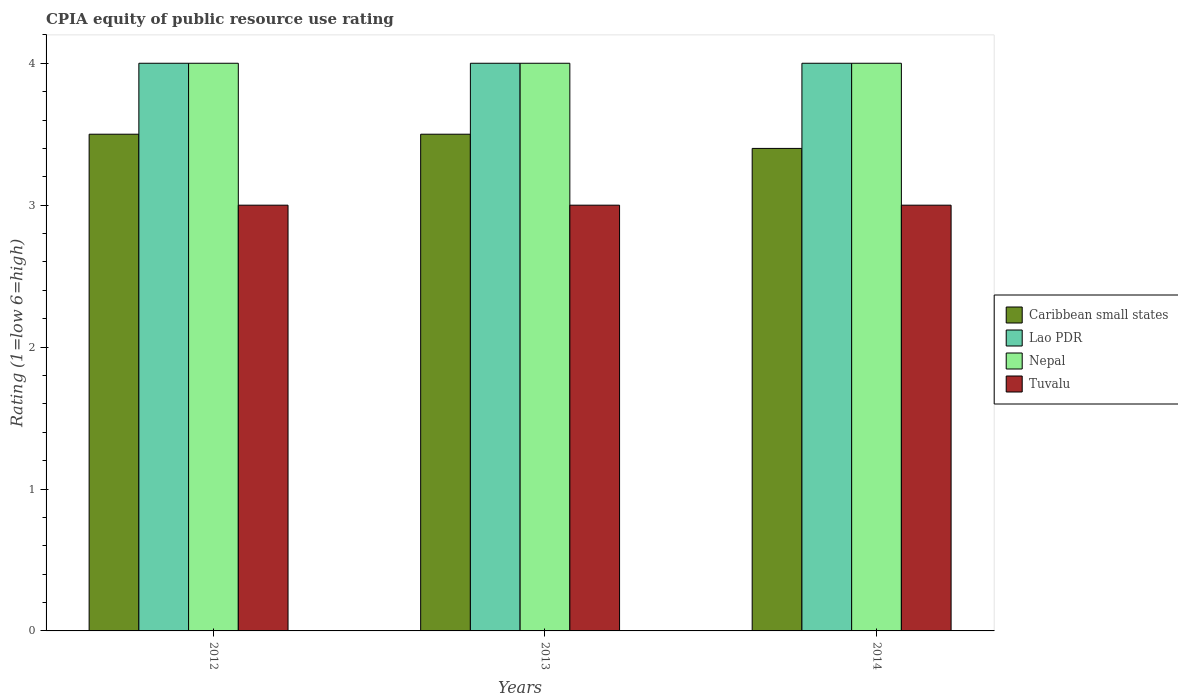Are the number of bars on each tick of the X-axis equal?
Provide a succinct answer. Yes. How many bars are there on the 1st tick from the left?
Your response must be concise. 4. In how many cases, is the number of bars for a given year not equal to the number of legend labels?
Make the answer very short. 0. What is the CPIA rating in Nepal in 2013?
Offer a terse response. 4. Across all years, what is the maximum CPIA rating in Nepal?
Provide a succinct answer. 4. Across all years, what is the minimum CPIA rating in Nepal?
Give a very brief answer. 4. In which year was the CPIA rating in Lao PDR maximum?
Offer a very short reply. 2012. What is the total CPIA rating in Caribbean small states in the graph?
Give a very brief answer. 10.4. What is the difference between the CPIA rating in Caribbean small states in 2012 and the CPIA rating in Tuvalu in 2013?
Offer a terse response. 0.5. In the year 2014, what is the difference between the CPIA rating in Tuvalu and CPIA rating in Nepal?
Give a very brief answer. -1. Is the difference between the CPIA rating in Tuvalu in 2012 and 2013 greater than the difference between the CPIA rating in Nepal in 2012 and 2013?
Keep it short and to the point. No. What is the difference between the highest and the second highest CPIA rating in Lao PDR?
Keep it short and to the point. 0. Is it the case that in every year, the sum of the CPIA rating in Lao PDR and CPIA rating in Caribbean small states is greater than the sum of CPIA rating in Nepal and CPIA rating in Tuvalu?
Ensure brevity in your answer.  No. What does the 2nd bar from the left in 2013 represents?
Offer a very short reply. Lao PDR. What does the 3rd bar from the right in 2013 represents?
Make the answer very short. Lao PDR. Is it the case that in every year, the sum of the CPIA rating in Lao PDR and CPIA rating in Nepal is greater than the CPIA rating in Caribbean small states?
Offer a terse response. Yes. How many years are there in the graph?
Your response must be concise. 3. What is the difference between two consecutive major ticks on the Y-axis?
Your answer should be very brief. 1. Are the values on the major ticks of Y-axis written in scientific E-notation?
Ensure brevity in your answer.  No. Does the graph contain grids?
Your answer should be compact. No. What is the title of the graph?
Provide a short and direct response. CPIA equity of public resource use rating. Does "Saudi Arabia" appear as one of the legend labels in the graph?
Keep it short and to the point. No. What is the label or title of the X-axis?
Provide a short and direct response. Years. What is the label or title of the Y-axis?
Ensure brevity in your answer.  Rating (1=low 6=high). What is the Rating (1=low 6=high) in Caribbean small states in 2013?
Give a very brief answer. 3.5. What is the Rating (1=low 6=high) of Caribbean small states in 2014?
Offer a very short reply. 3.4. What is the Rating (1=low 6=high) in Lao PDR in 2014?
Offer a very short reply. 4. What is the Rating (1=low 6=high) of Tuvalu in 2014?
Offer a terse response. 3. Across all years, what is the maximum Rating (1=low 6=high) in Nepal?
Give a very brief answer. 4. Across all years, what is the maximum Rating (1=low 6=high) in Tuvalu?
Make the answer very short. 3. Across all years, what is the minimum Rating (1=low 6=high) in Nepal?
Your answer should be compact. 4. What is the total Rating (1=low 6=high) of Caribbean small states in the graph?
Your response must be concise. 10.4. What is the total Rating (1=low 6=high) of Lao PDR in the graph?
Make the answer very short. 12. What is the total Rating (1=low 6=high) of Tuvalu in the graph?
Your answer should be very brief. 9. What is the difference between the Rating (1=low 6=high) in Lao PDR in 2012 and that in 2013?
Your answer should be compact. 0. What is the difference between the Rating (1=low 6=high) in Nepal in 2012 and that in 2013?
Your answer should be compact. 0. What is the difference between the Rating (1=low 6=high) in Lao PDR in 2012 and that in 2014?
Offer a terse response. 0. What is the difference between the Rating (1=low 6=high) in Nepal in 2012 and that in 2014?
Provide a short and direct response. 0. What is the difference between the Rating (1=low 6=high) of Lao PDR in 2013 and that in 2014?
Your answer should be very brief. 0. What is the difference between the Rating (1=low 6=high) in Nepal in 2013 and that in 2014?
Provide a short and direct response. 0. What is the difference between the Rating (1=low 6=high) in Tuvalu in 2013 and that in 2014?
Your response must be concise. 0. What is the difference between the Rating (1=low 6=high) in Caribbean small states in 2012 and the Rating (1=low 6=high) in Lao PDR in 2013?
Offer a very short reply. -0.5. What is the difference between the Rating (1=low 6=high) in Caribbean small states in 2012 and the Rating (1=low 6=high) in Nepal in 2013?
Make the answer very short. -0.5. What is the difference between the Rating (1=low 6=high) in Lao PDR in 2012 and the Rating (1=low 6=high) in Tuvalu in 2013?
Provide a succinct answer. 1. What is the difference between the Rating (1=low 6=high) of Nepal in 2012 and the Rating (1=low 6=high) of Tuvalu in 2013?
Your answer should be very brief. 1. What is the difference between the Rating (1=low 6=high) of Caribbean small states in 2012 and the Rating (1=low 6=high) of Lao PDR in 2014?
Keep it short and to the point. -0.5. What is the difference between the Rating (1=low 6=high) of Caribbean small states in 2012 and the Rating (1=low 6=high) of Nepal in 2014?
Offer a terse response. -0.5. What is the difference between the Rating (1=low 6=high) in Caribbean small states in 2013 and the Rating (1=low 6=high) in Lao PDR in 2014?
Make the answer very short. -0.5. What is the difference between the Rating (1=low 6=high) in Caribbean small states in 2013 and the Rating (1=low 6=high) in Tuvalu in 2014?
Your response must be concise. 0.5. What is the average Rating (1=low 6=high) in Caribbean small states per year?
Your answer should be very brief. 3.47. What is the average Rating (1=low 6=high) of Lao PDR per year?
Your answer should be compact. 4. What is the average Rating (1=low 6=high) of Nepal per year?
Give a very brief answer. 4. In the year 2012, what is the difference between the Rating (1=low 6=high) in Caribbean small states and Rating (1=low 6=high) in Lao PDR?
Offer a very short reply. -0.5. In the year 2012, what is the difference between the Rating (1=low 6=high) of Caribbean small states and Rating (1=low 6=high) of Tuvalu?
Provide a succinct answer. 0.5. In the year 2012, what is the difference between the Rating (1=low 6=high) in Lao PDR and Rating (1=low 6=high) in Nepal?
Your answer should be very brief. 0. In the year 2012, what is the difference between the Rating (1=low 6=high) in Nepal and Rating (1=low 6=high) in Tuvalu?
Make the answer very short. 1. In the year 2013, what is the difference between the Rating (1=low 6=high) of Caribbean small states and Rating (1=low 6=high) of Nepal?
Provide a short and direct response. -0.5. In the year 2014, what is the difference between the Rating (1=low 6=high) in Caribbean small states and Rating (1=low 6=high) in Lao PDR?
Your answer should be compact. -0.6. What is the ratio of the Rating (1=low 6=high) in Nepal in 2012 to that in 2013?
Keep it short and to the point. 1. What is the ratio of the Rating (1=low 6=high) of Tuvalu in 2012 to that in 2013?
Your answer should be very brief. 1. What is the ratio of the Rating (1=low 6=high) in Caribbean small states in 2012 to that in 2014?
Offer a terse response. 1.03. What is the ratio of the Rating (1=low 6=high) of Nepal in 2012 to that in 2014?
Make the answer very short. 1. What is the ratio of the Rating (1=low 6=high) in Caribbean small states in 2013 to that in 2014?
Your answer should be very brief. 1.03. What is the ratio of the Rating (1=low 6=high) of Lao PDR in 2013 to that in 2014?
Offer a terse response. 1. What is the ratio of the Rating (1=low 6=high) in Tuvalu in 2013 to that in 2014?
Your response must be concise. 1. What is the difference between the highest and the second highest Rating (1=low 6=high) of Lao PDR?
Provide a short and direct response. 0. What is the difference between the highest and the second highest Rating (1=low 6=high) in Tuvalu?
Provide a short and direct response. 0. What is the difference between the highest and the lowest Rating (1=low 6=high) in Caribbean small states?
Your answer should be compact. 0.1. What is the difference between the highest and the lowest Rating (1=low 6=high) of Lao PDR?
Offer a very short reply. 0. What is the difference between the highest and the lowest Rating (1=low 6=high) in Tuvalu?
Your answer should be very brief. 0. 